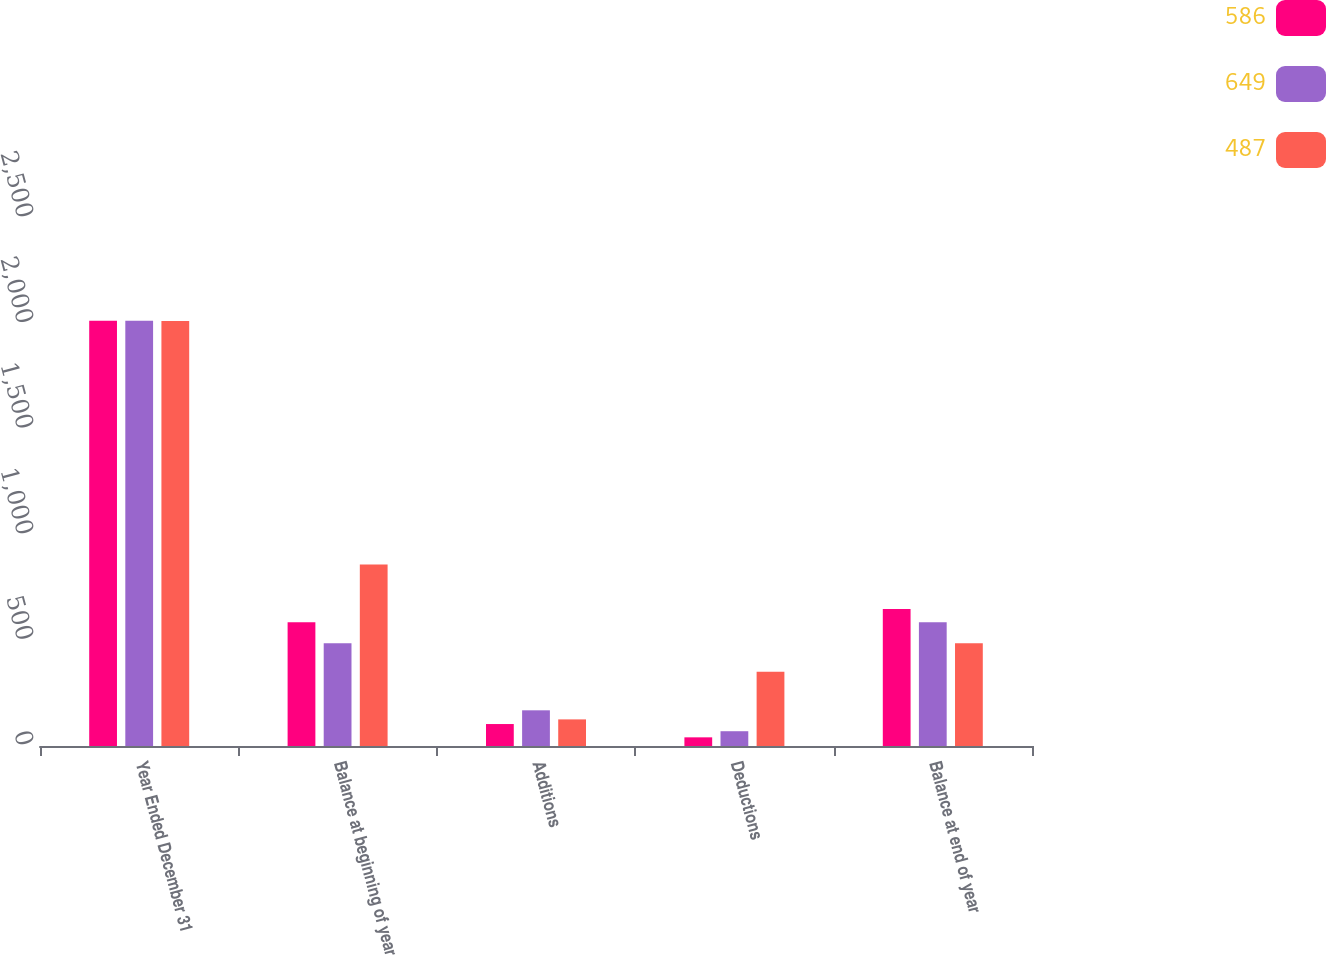Convert chart to OTSL. <chart><loc_0><loc_0><loc_500><loc_500><stacked_bar_chart><ecel><fcel>Year Ended December 31<fcel>Balance at beginning of year<fcel>Additions<fcel>Deductions<fcel>Balance at end of year<nl><fcel>586<fcel>2014<fcel>586<fcel>104<fcel>41<fcel>649<nl><fcel>649<fcel>2013<fcel>487<fcel>169<fcel>70<fcel>586<nl><fcel>487<fcel>2012<fcel>859<fcel>126<fcel>352<fcel>487<nl></chart> 